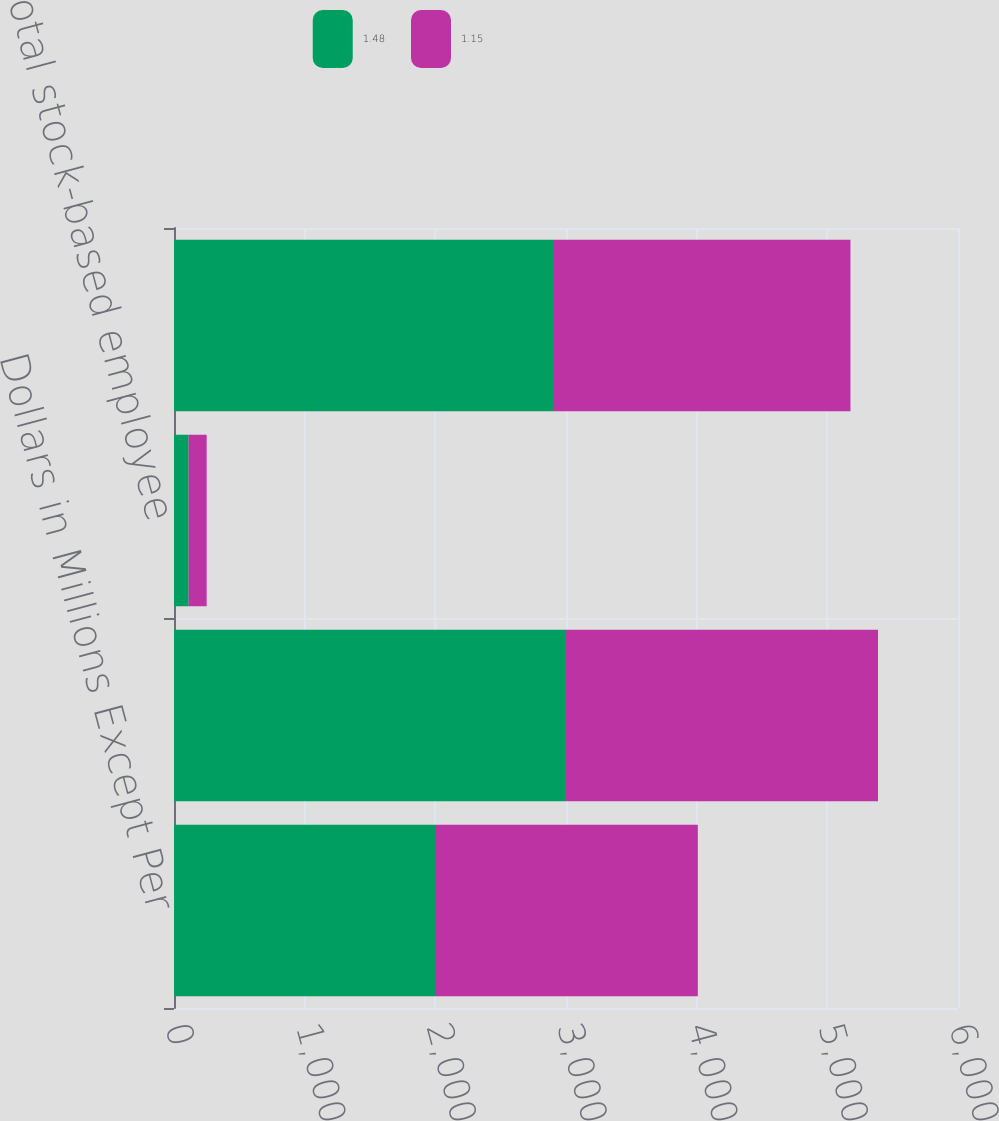Convert chart to OTSL. <chart><loc_0><loc_0><loc_500><loc_500><stacked_bar_chart><ecel><fcel>Dollars in Millions Except Per<fcel>As reported<fcel>Total stock-based employee<fcel>Pro forma<nl><fcel>1.48<fcel>2005<fcel>3000<fcel>112<fcel>2908<nl><fcel>1.15<fcel>2004<fcel>2388<fcel>138<fcel>2269<nl></chart> 